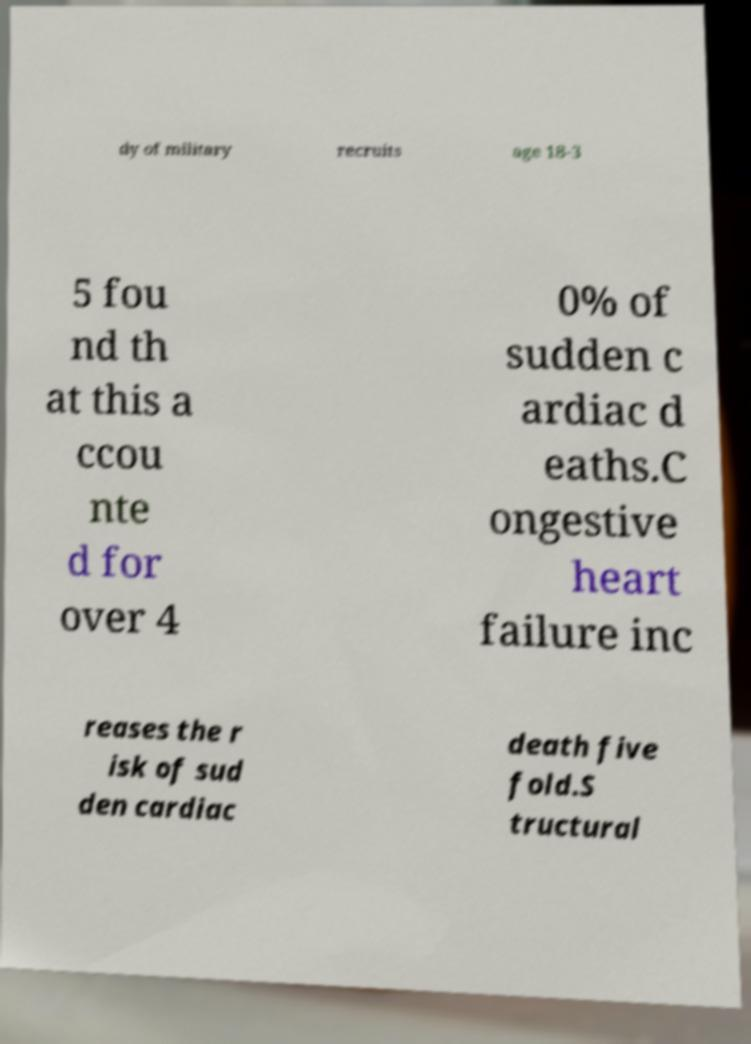There's text embedded in this image that I need extracted. Can you transcribe it verbatim? dy of military recruits age 18-3 5 fou nd th at this a ccou nte d for over 4 0% of sudden c ardiac d eaths.C ongestive heart failure inc reases the r isk of sud den cardiac death five fold.S tructural 